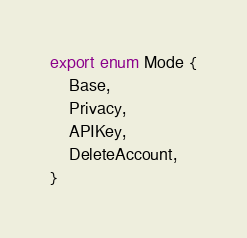Convert code to text. <code><loc_0><loc_0><loc_500><loc_500><_TypeScript_>export enum Mode {
	Base,
	Privacy,
	APIKey,
	DeleteAccount,
}
</code> 